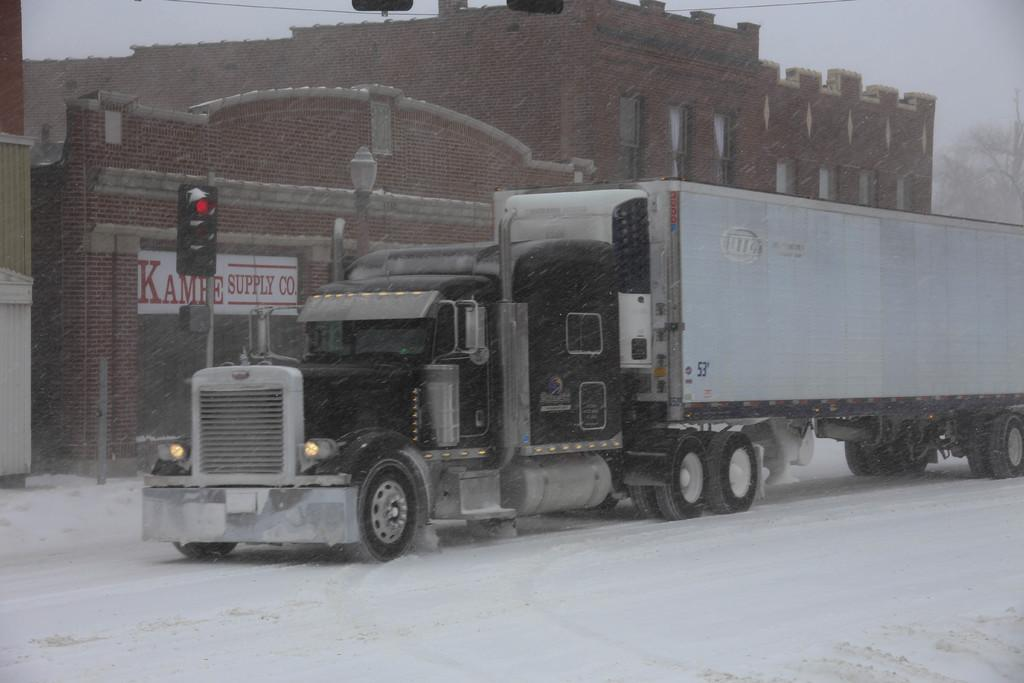What is on the snow in the image? There is a vehicle on the surface of the snow in the image. What is located behind the vehicle? There is a traffic signal behind the vehicle. What can be seen in the distance in the image? There are buildings, trees, and the sky visible in the background of the image. What is the texture of the sneeze coming from the person in the image? There is no person sneezing in the image, and therefore no sneeze to describe the texture of. 